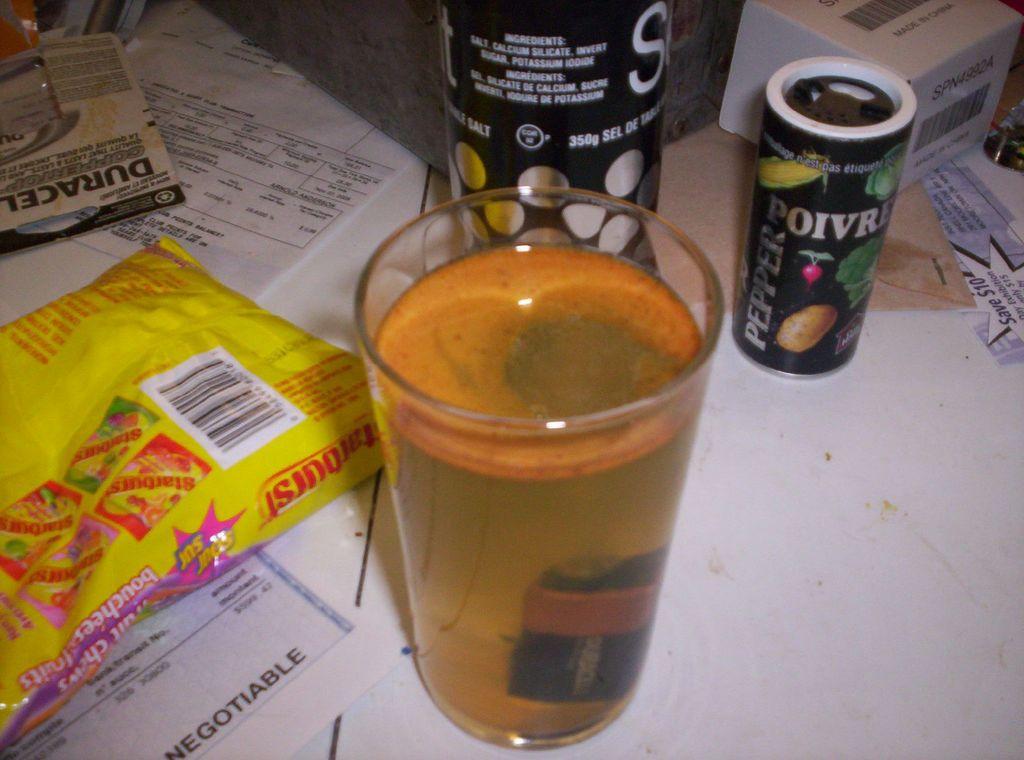What candy is shown here?
Give a very brief answer. Starburst. What is in the small shaker to the right?
Make the answer very short. Pepper. 